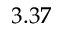<formula> <loc_0><loc_0><loc_500><loc_500>3 . 3 7</formula> 